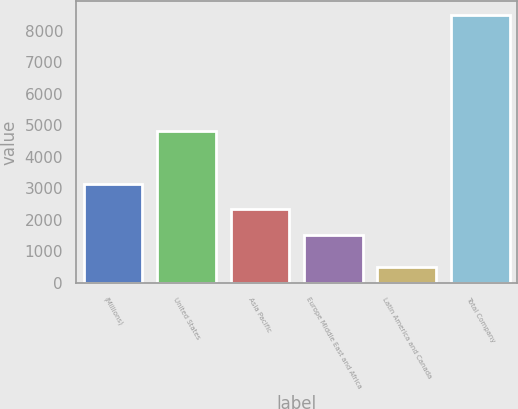Convert chart to OTSL. <chart><loc_0><loc_0><loc_500><loc_500><bar_chart><fcel>(Millions)<fcel>United States<fcel>Asia Pacific<fcel>Europe Middle East and Africa<fcel>Latin America and Canada<fcel>Total Company<nl><fcel>3134.2<fcel>4838<fcel>2332.6<fcel>1531<fcel>499<fcel>8515<nl></chart> 